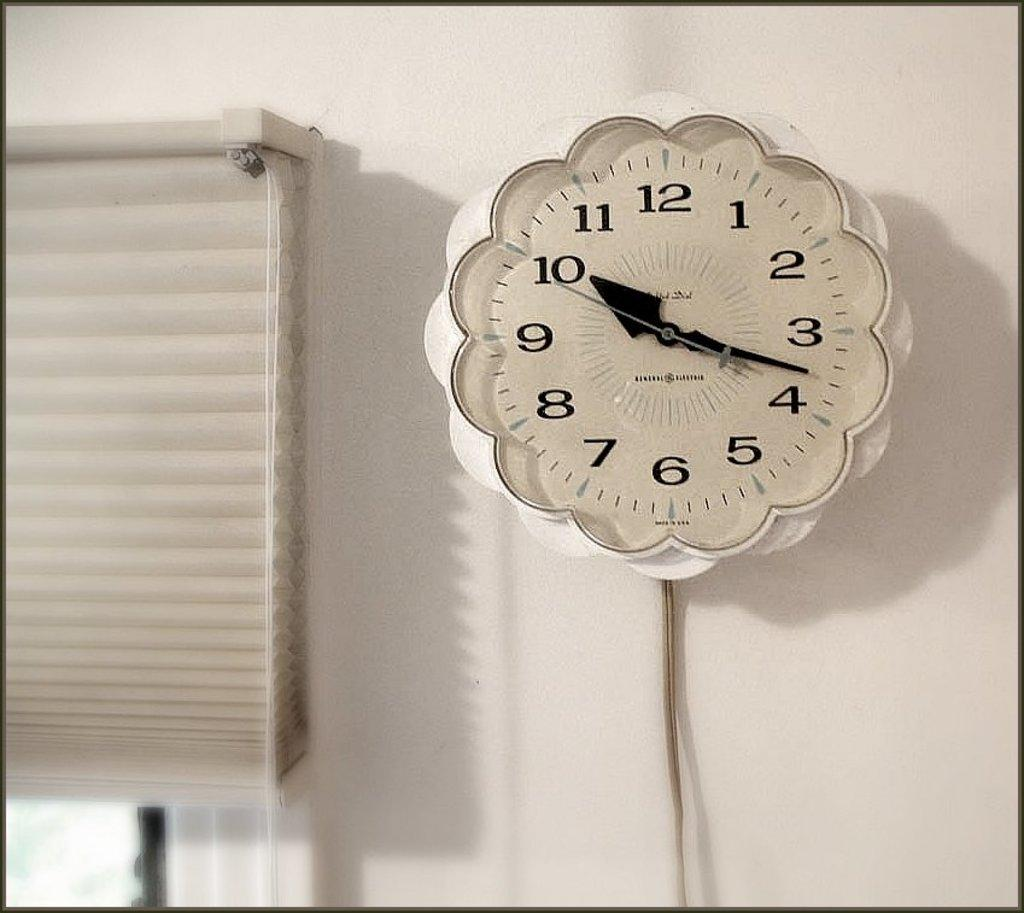<image>
Render a clear and concise summary of the photo. White clock with the hands on the number 10 and 4. 